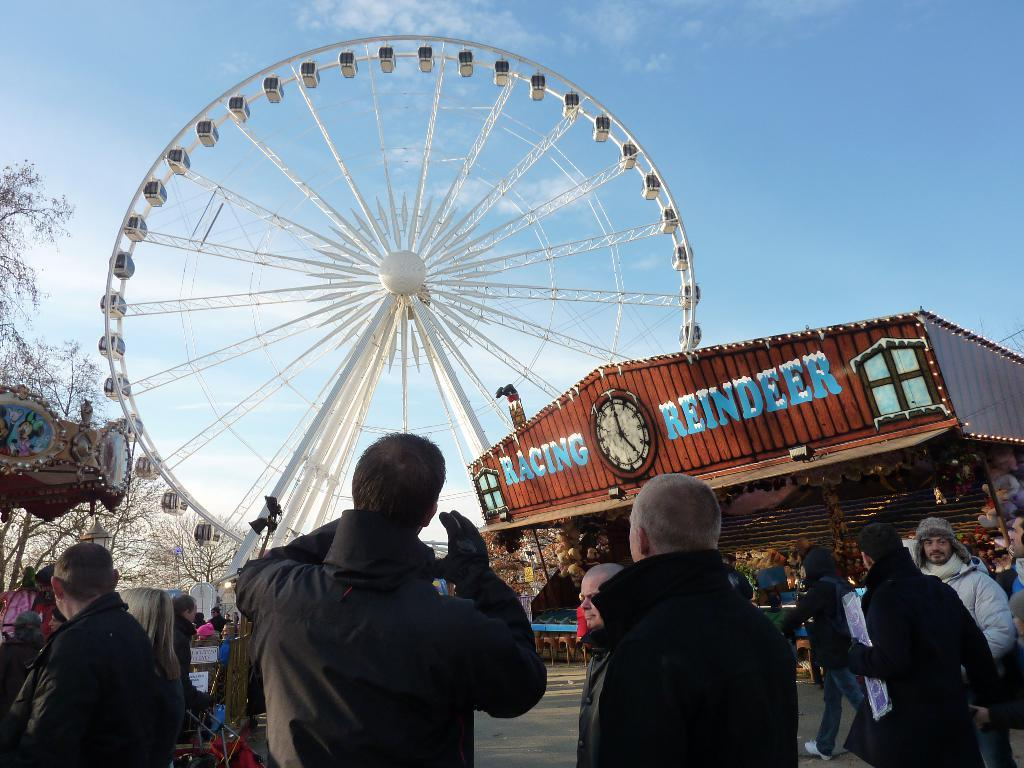What can be seen in the image? There are people standing in the image, along with a building, a giant wheel, trees, other objects on the ground, and the sky visible in the background. Can you describe the people in the image? The facts provided do not give specific details about the people, but they are present in the image. What is the giant wheel used for? The giant wheel is a common amusement park ride, so it is likely being used for entertainment purposes. What type of objects are on the ground in the image? The facts provided do not specify the types of objects on the ground, but they are present in the image. What room is the representative attacking in the image? There is no representative or attack present in the image; it features people, a building, a giant wheel, trees, and other objects on the ground. 